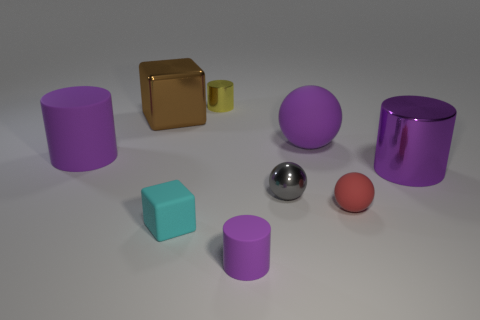Subtract all tiny gray spheres. How many spheres are left? 2 Subtract all cyan spheres. How many purple cylinders are left? 3 Add 1 gray shiny things. How many objects exist? 10 Subtract all yellow cylinders. How many cylinders are left? 3 Subtract all spheres. How many objects are left? 6 Subtract all large red metallic cylinders. Subtract all tiny metal cylinders. How many objects are left? 8 Add 2 purple matte objects. How many purple matte objects are left? 5 Add 2 big red metal spheres. How many big red metal spheres exist? 2 Subtract 1 brown cubes. How many objects are left? 8 Subtract all gray cylinders. Subtract all brown spheres. How many cylinders are left? 4 